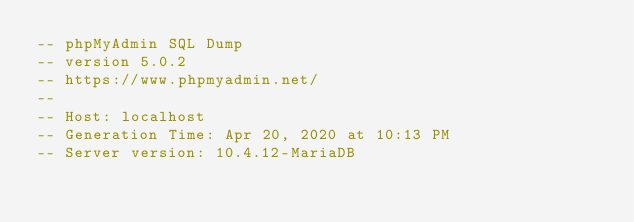Convert code to text. <code><loc_0><loc_0><loc_500><loc_500><_SQL_>-- phpMyAdmin SQL Dump
-- version 5.0.2
-- https://www.phpmyadmin.net/
--
-- Host: localhost
-- Generation Time: Apr 20, 2020 at 10:13 PM
-- Server version: 10.4.12-MariaDB</code> 